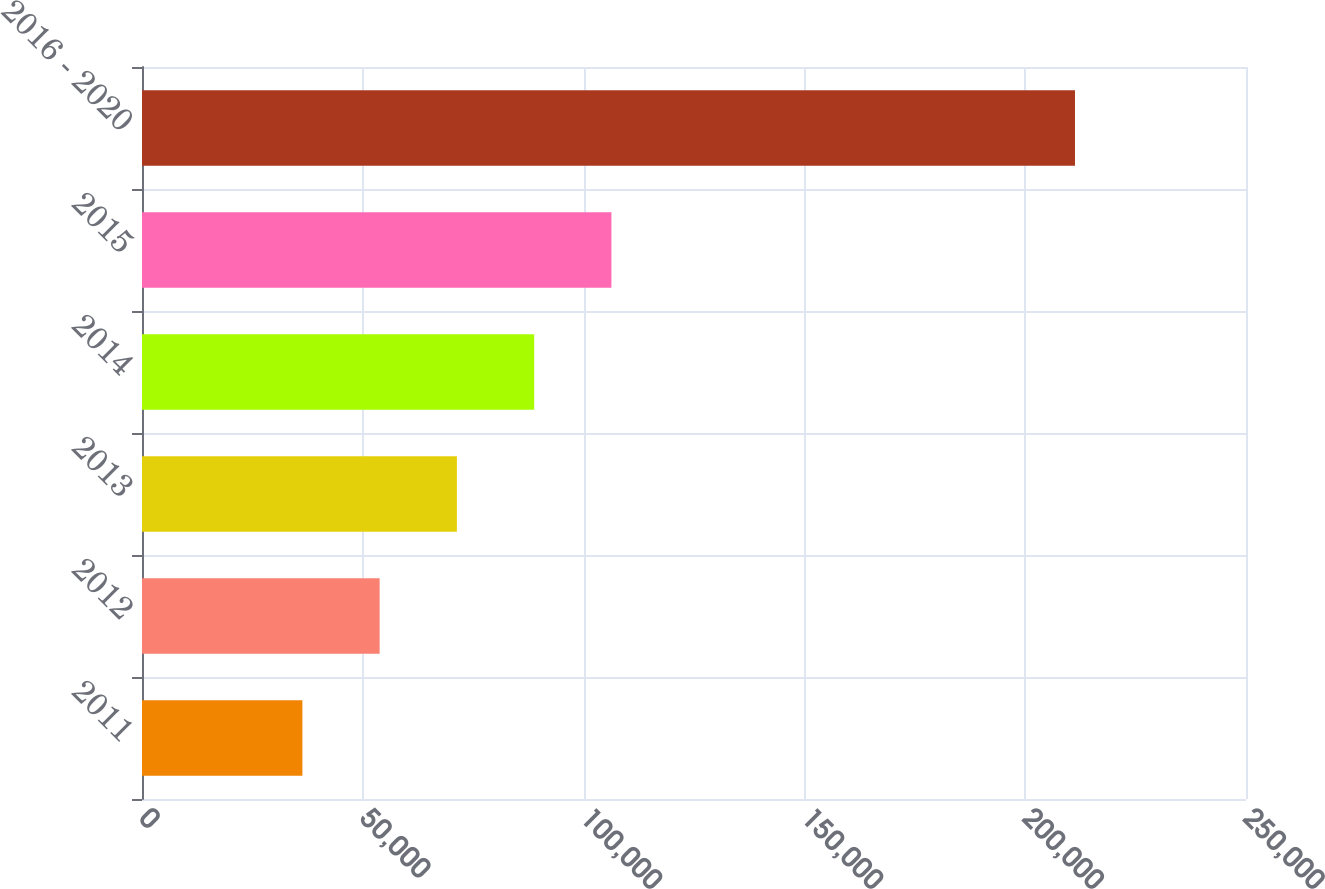Convert chart. <chart><loc_0><loc_0><loc_500><loc_500><bar_chart><fcel>2011<fcel>2012<fcel>2013<fcel>2014<fcel>2015<fcel>2016 - 2020<nl><fcel>36320<fcel>53815.5<fcel>71311<fcel>88806.5<fcel>106302<fcel>211275<nl></chart> 